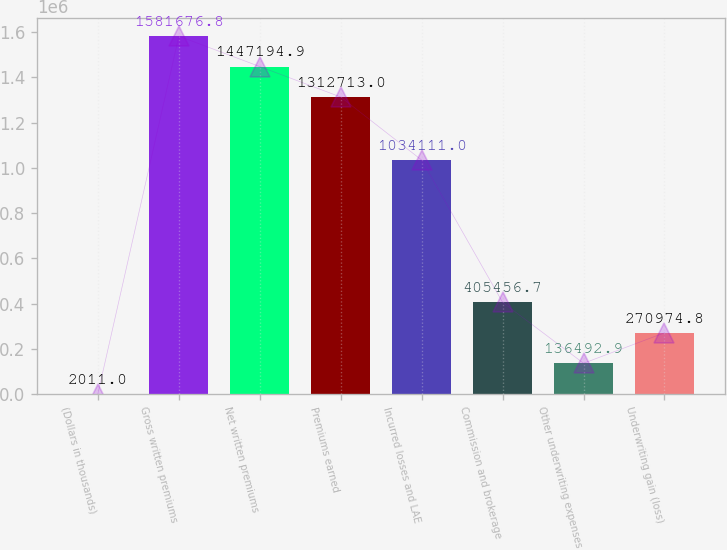Convert chart. <chart><loc_0><loc_0><loc_500><loc_500><bar_chart><fcel>(Dollars in thousands)<fcel>Gross written premiums<fcel>Net written premiums<fcel>Premiums earned<fcel>Incurred losses and LAE<fcel>Commission and brokerage<fcel>Other underwriting expenses<fcel>Underwriting gain (loss)<nl><fcel>2011<fcel>1.58168e+06<fcel>1.44719e+06<fcel>1.31271e+06<fcel>1.03411e+06<fcel>405457<fcel>136493<fcel>270975<nl></chart> 